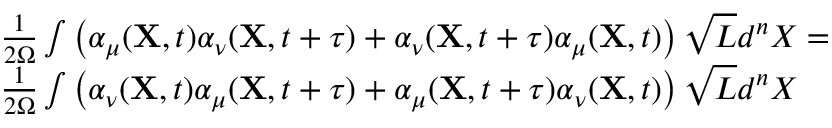Convert formula to latex. <formula><loc_0><loc_0><loc_500><loc_500>\begin{array} { r l } & { \frac { 1 } { 2 \Omega } \int \left ( \alpha _ { \mu } ( { X } , t ) \alpha _ { \nu } ( { X } , t + \tau ) + \alpha _ { \nu } ( { X } , t + \tau ) \alpha _ { \mu } ( { X } , t ) \right ) \sqrt { L } d ^ { n } X = } \\ & { \frac { 1 } { 2 \Omega } \int \left ( \alpha _ { \nu } ( { X } , t ) \alpha _ { \mu } ( { X } , t + \tau ) + \alpha _ { \mu } ( { X } , t + \tau ) \alpha _ { \nu } ( { X } , t ) \right ) \sqrt { L } d ^ { n } X } \end{array}</formula> 